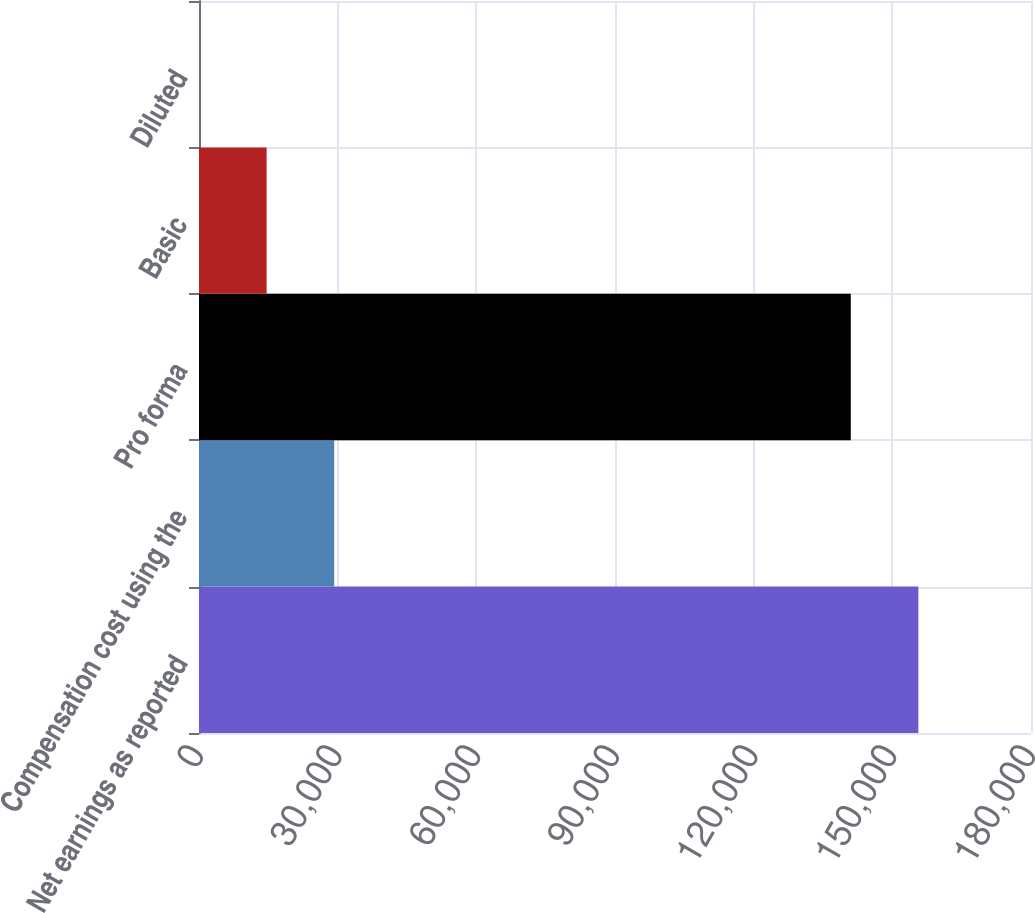Convert chart to OTSL. <chart><loc_0><loc_0><loc_500><loc_500><bar_chart><fcel>Net earnings as reported<fcel>Compensation cost using the<fcel>Pro forma<fcel>Basic<fcel>Diluted<nl><fcel>155636<fcel>29251.9<fcel>141010<fcel>14626.4<fcel>0.88<nl></chart> 